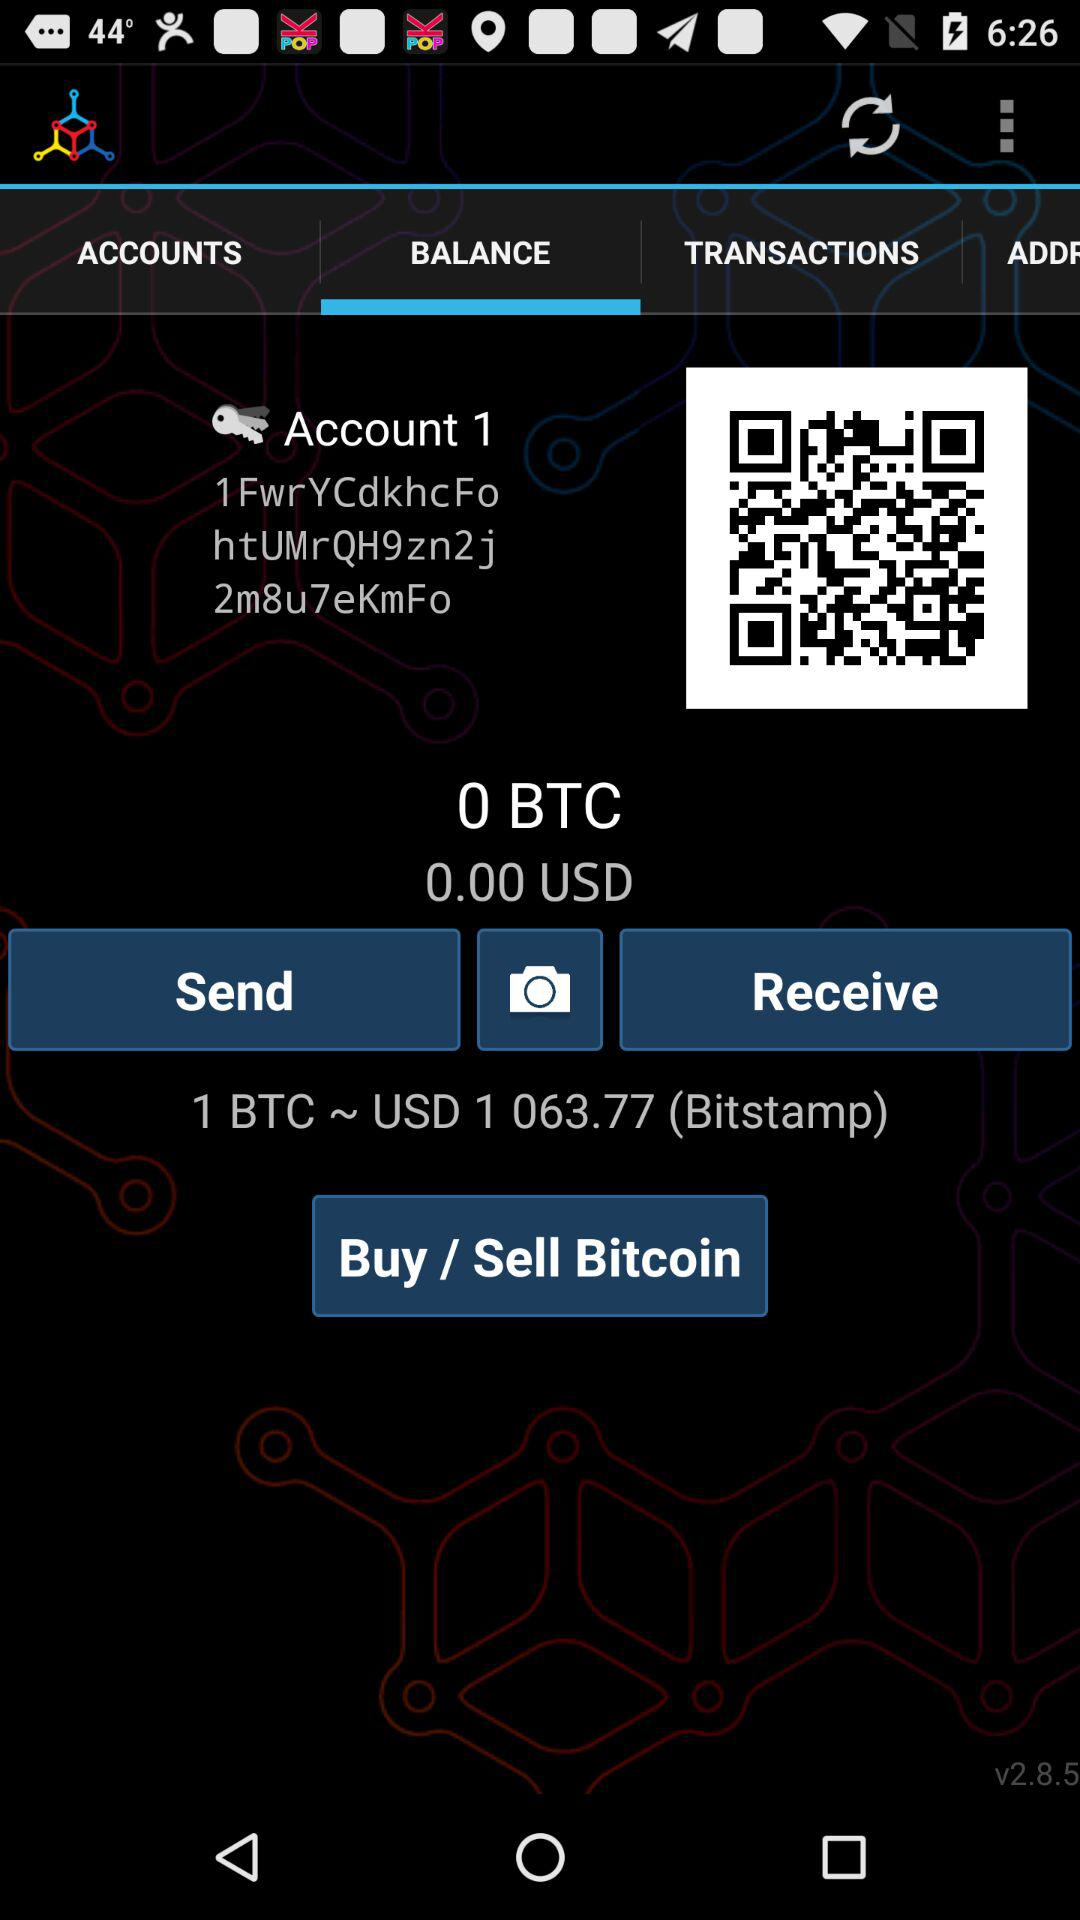Which tab is selected? The selected tab is "BALANCE". 